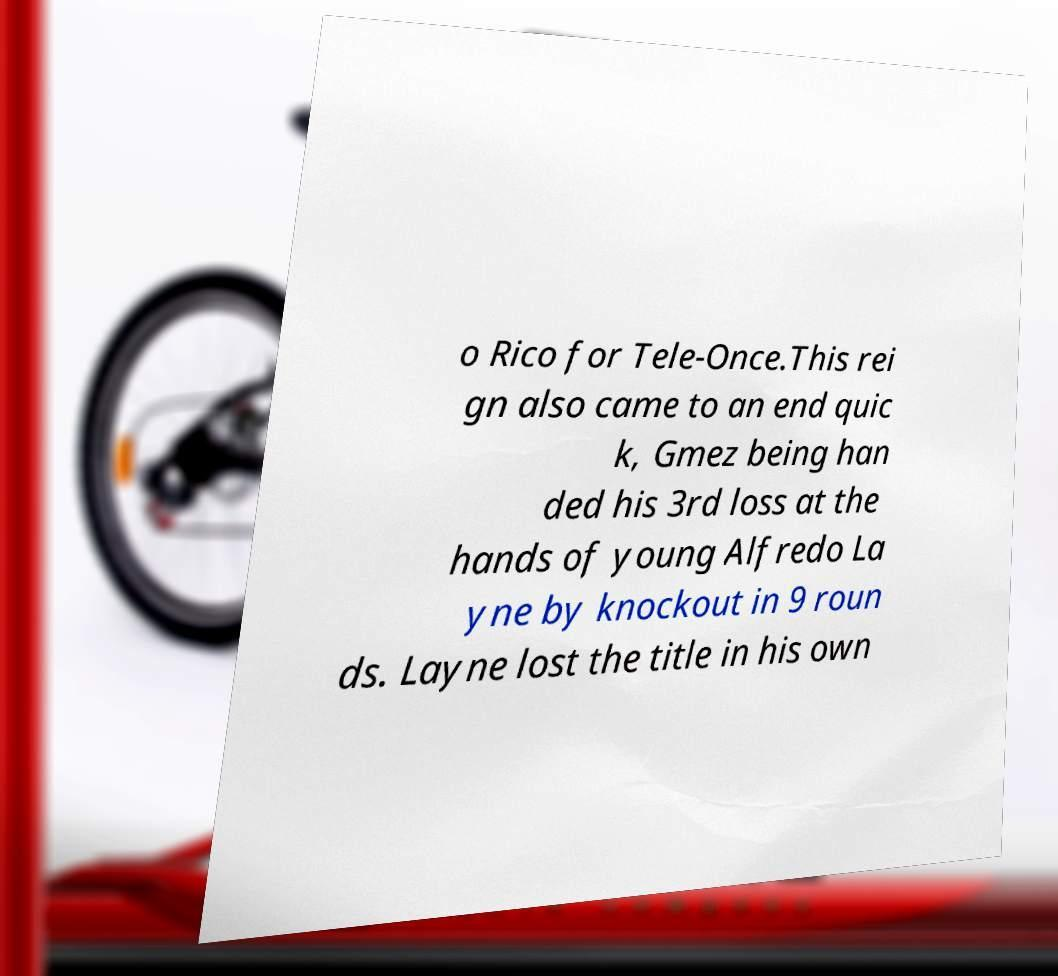For documentation purposes, I need the text within this image transcribed. Could you provide that? o Rico for Tele-Once.This rei gn also came to an end quic k, Gmez being han ded his 3rd loss at the hands of young Alfredo La yne by knockout in 9 roun ds. Layne lost the title in his own 